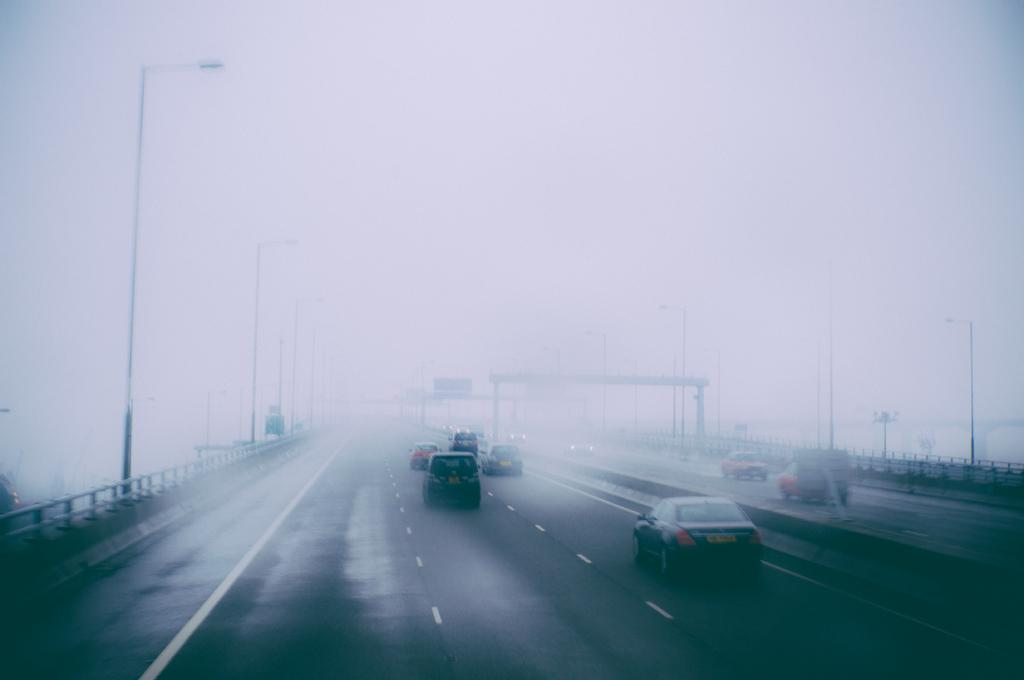What can be seen in the center of the image? There are vehicles on the road in the center of the image. Are there any structures visible in the image? Yes, there are light poles in the image. What is the weather condition in the background of the image? There is fog visible in the background of the image. What team is responsible for maintaining the condition of the road in the image? There is no information about a team responsible for maintaining the road in the image. 